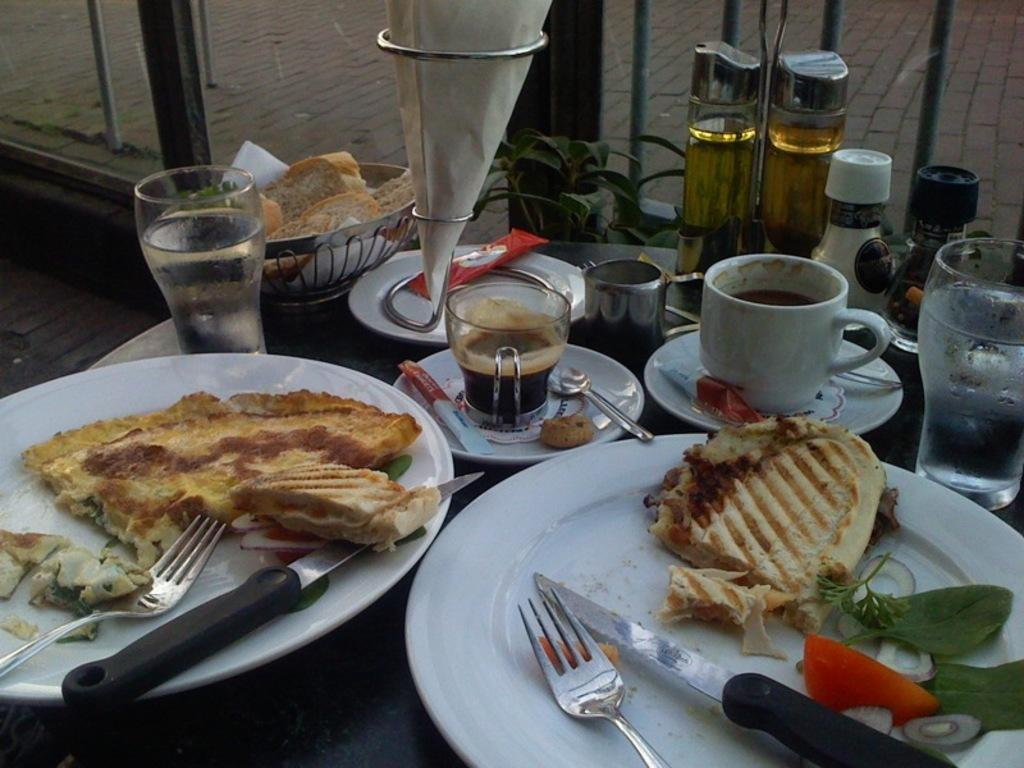What type of furniture is present in the image? There is a table in the image. What items can be seen on the table? There are plates, knives, glasses, bottles, cups, and tissues on the table. What brand of toothpaste is advertised on the table in the image? There is no toothpaste present in the image, so it cannot be determined if any brand is advertised. 